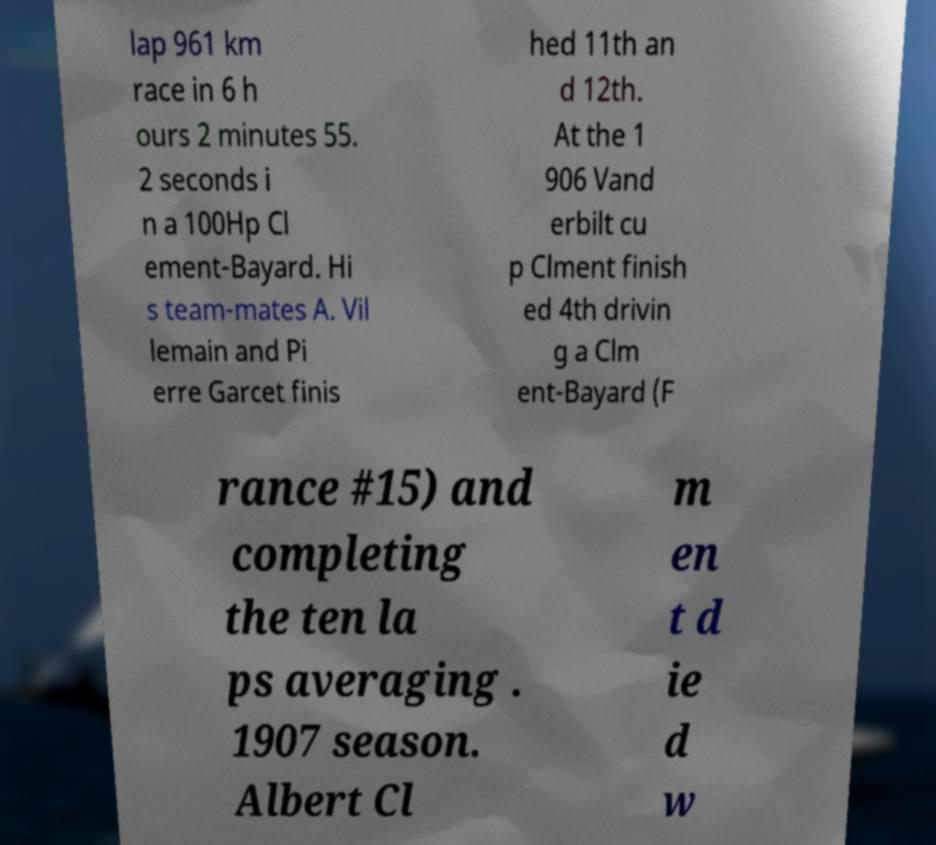I need the written content from this picture converted into text. Can you do that? lap 961 km race in 6 h ours 2 minutes 55. 2 seconds i n a 100Hp Cl ement-Bayard. Hi s team-mates A. Vil lemain and Pi erre Garcet finis hed 11th an d 12th. At the 1 906 Vand erbilt cu p Clment finish ed 4th drivin g a Clm ent-Bayard (F rance #15) and completing the ten la ps averaging . 1907 season. Albert Cl m en t d ie d w 